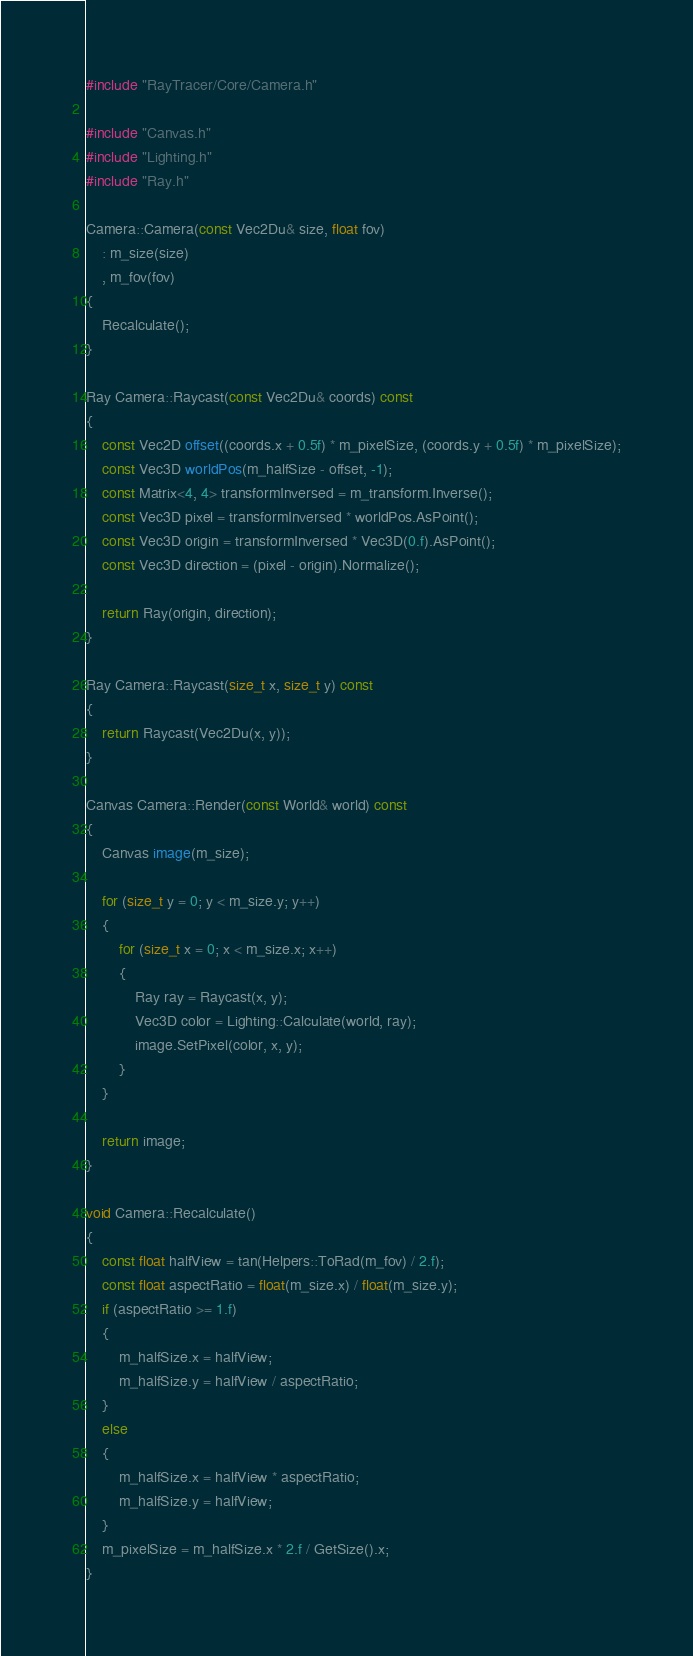<code> <loc_0><loc_0><loc_500><loc_500><_C++_>#include "RayTracer/Core/Camera.h"

#include "Canvas.h"
#include "Lighting.h"
#include "Ray.h"

Camera::Camera(const Vec2Du& size, float fov)
    : m_size(size)
    , m_fov(fov)
{
    Recalculate();
}

Ray Camera::Raycast(const Vec2Du& coords) const
{
    const Vec2D offset((coords.x + 0.5f) * m_pixelSize, (coords.y + 0.5f) * m_pixelSize);
    const Vec3D worldPos(m_halfSize - offset, -1);
    const Matrix<4, 4> transformInversed = m_transform.Inverse();
    const Vec3D pixel = transformInversed * worldPos.AsPoint();
    const Vec3D origin = transformInversed * Vec3D(0.f).AsPoint();
    const Vec3D direction = (pixel - origin).Normalize();

    return Ray(origin, direction);
}

Ray Camera::Raycast(size_t x, size_t y) const
{
    return Raycast(Vec2Du(x, y));
}

Canvas Camera::Render(const World& world) const
{
    Canvas image(m_size);

    for (size_t y = 0; y < m_size.y; y++)
    {
        for (size_t x = 0; x < m_size.x; x++)
        {
            Ray ray = Raycast(x, y);
            Vec3D color = Lighting::Calculate(world, ray);
            image.SetPixel(color, x, y);
        }
    }

    return image;
}

void Camera::Recalculate()
{
    const float halfView = tan(Helpers::ToRad(m_fov) / 2.f);
    const float aspectRatio = float(m_size.x) / float(m_size.y);
    if (aspectRatio >= 1.f)
    {
        m_halfSize.x = halfView;
        m_halfSize.y = halfView / aspectRatio;
    }
    else
    {
        m_halfSize.x = halfView * aspectRatio;
        m_halfSize.y = halfView;
    }
    m_pixelSize = m_halfSize.x * 2.f / GetSize().x;
}
</code> 